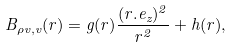<formula> <loc_0><loc_0><loc_500><loc_500>B _ { \rho v , v } ( r ) = g ( r ) \frac { ( r . e _ { z } ) ^ { 2 } } { r ^ { 2 } } + h ( r ) ,</formula> 